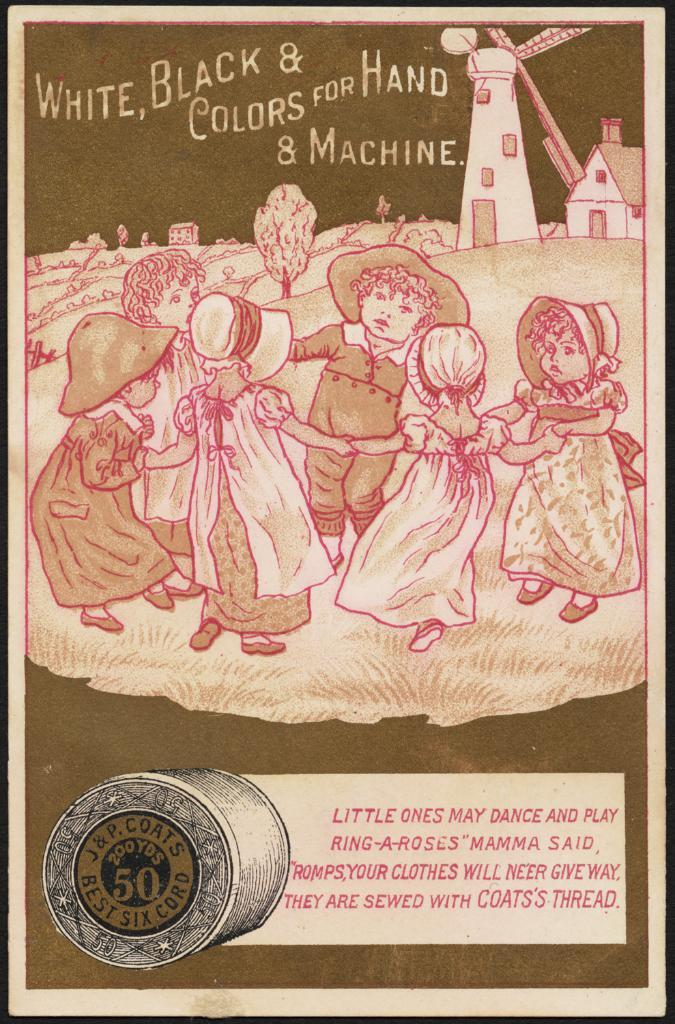Who is present in the image? There are children depicted in the image. What type of structure can be seen in the image? There is a house in the image. What other objects can be seen in the image? There is a windmill and trees in the image. Is there any text or writing in the image? Yes, there is writing present in the image. How many combs are being used by the children in the image? There is no mention of combs in the image, so it cannot be determined if any are being used. 